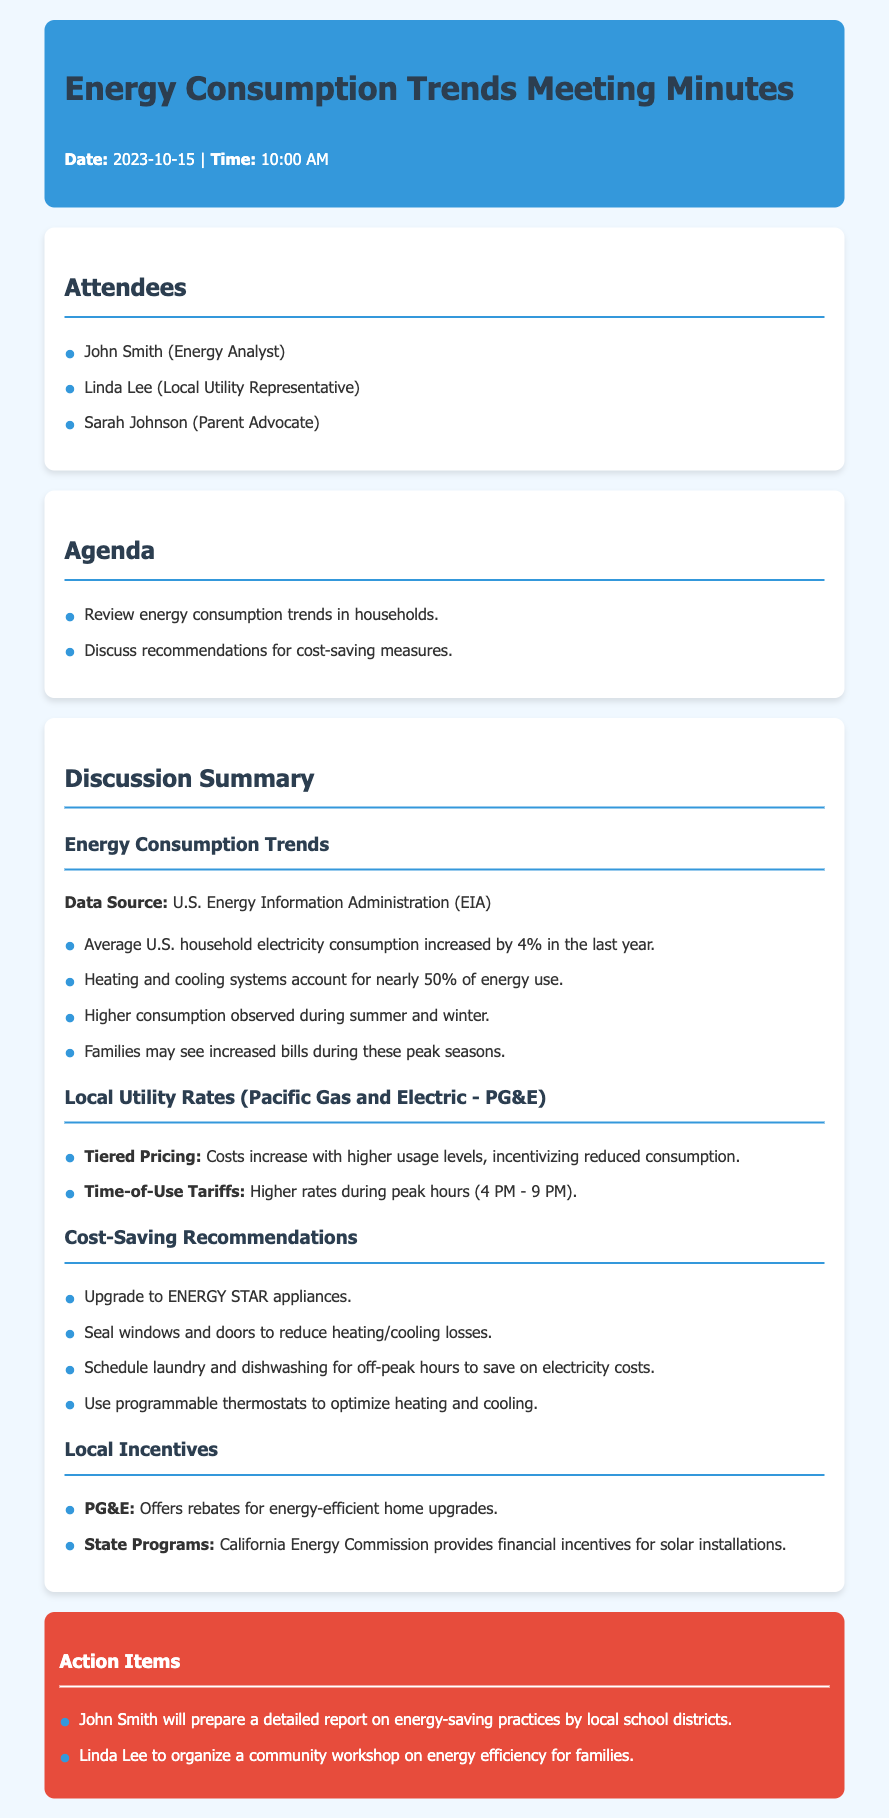What was the date of the meeting? The meeting took place on October 15, 2023.
Answer: October 15, 2023 Who is the local utility representative? Linda Lee is mentioned as the local utility representative in the attendees section.
Answer: Linda Lee What percentage of energy use is accounted for by heating and cooling systems? The document states that heating and cooling systems account for nearly 50% of energy use.
Answer: nearly 50% What is the peak rate time for energy consumption? The time-of-use tariffs indicate that higher rates occur during 4 PM to 9 PM.
Answer: 4 PM - 9 PM Which appliance upgrade is recommended for savings? The document suggests upgrading to ENERGY STAR appliances for cost savings.
Answer: ENERGY STAR appliances What rebates does PG&E offer? PG&E offers rebates for energy-efficient home upgrades as mentioned in the local incentives section.
Answer: rebates for energy-efficient home upgrades What action will John Smith take following the meeting? John Smith will prepare a detailed report on energy-saving practices by local school districts.
Answer: prepare a detailed report Why might families see increased bills during certain seasons? Increased bills may occur during peak seasons, specifically summer and winter, due to higher consumption.
Answer: summer and winter What financial incentives does the California Energy Commission provide? The document notes that the California Energy Commission provides financial incentives for solar installations.
Answer: financial incentives for solar installations 